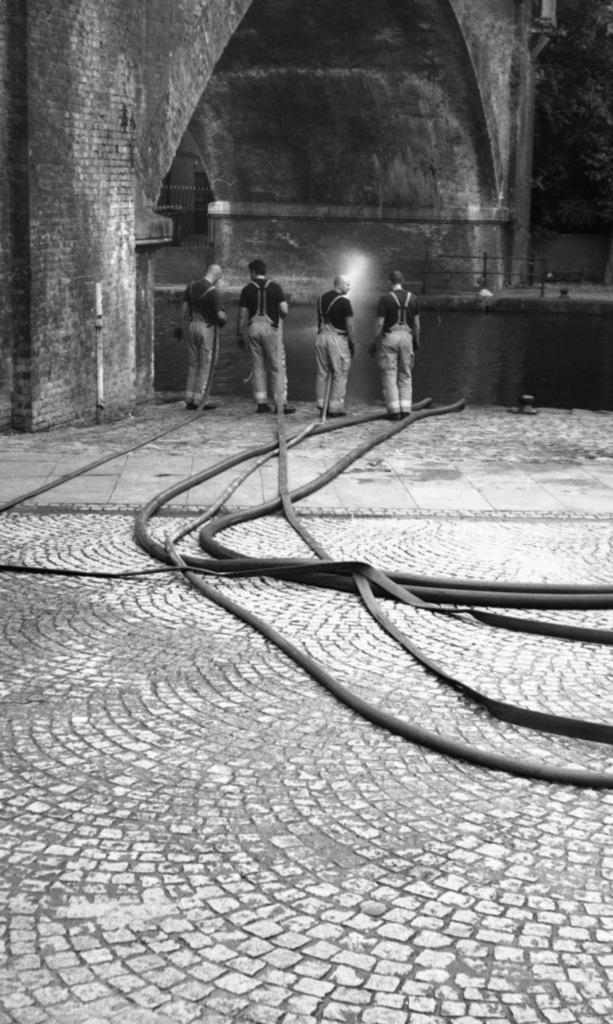Could you give a brief overview of what you see in this image? This image consists of four persons wearing black T-shirts. It looks like it is clicked inside the building or a fort. At the bottom, there are pipes on the ground. In the front, we can see a big wall. 